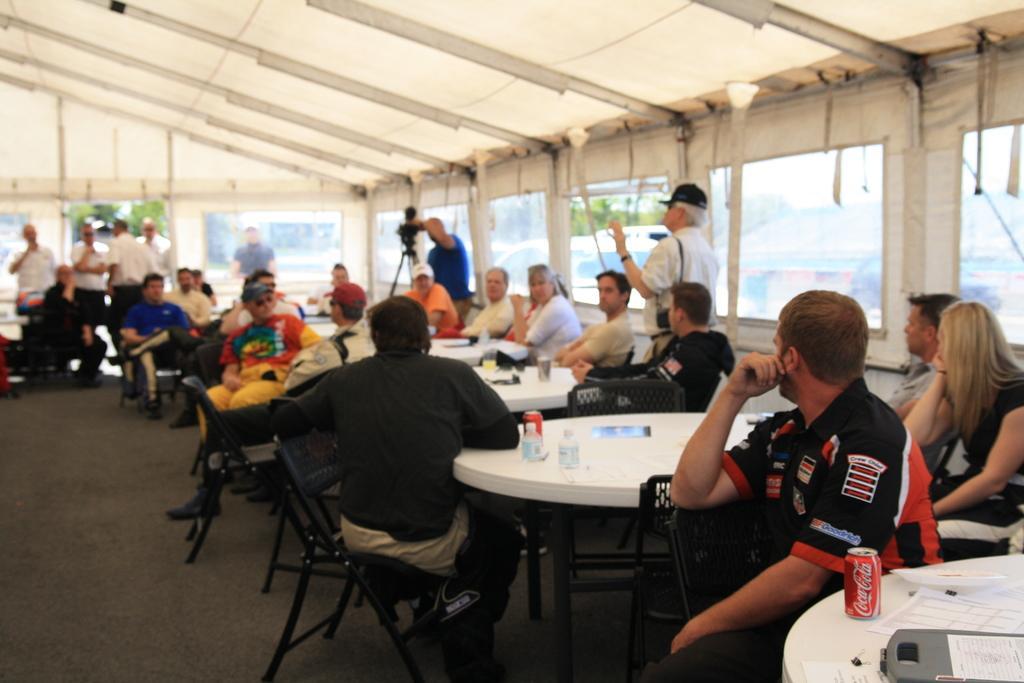Please provide a concise description of this image. In this picture, we see many people sitting on chair. In front of them, we see many white tables on which water bottle, coke bottle, paper are placed and in the middle of the picture, man in blue t-shirt is holding video camera and taking video in it. Behind this, we see a car moving on the road and we even see trees. I think this might be a tent. 